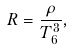Convert formula to latex. <formula><loc_0><loc_0><loc_500><loc_500>R = \frac { \rho } { T ^ { 3 } _ { 6 } } ,</formula> 